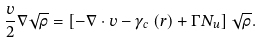Convert formula to latex. <formula><loc_0><loc_0><loc_500><loc_500>\frac { v } { 2 } \nabla \sqrt { \rho } = \left [ - \nabla \cdot { v } - \gamma _ { c } \left ( { r } \right ) + \Gamma N _ { u } \right ] \sqrt { \rho } .</formula> 